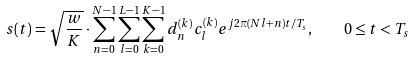<formula> <loc_0><loc_0><loc_500><loc_500>s ( t ) = \sqrt { \frac { w } { K } } \cdot \sum _ { n = 0 } ^ { N - 1 } \sum _ { l = 0 } ^ { L - 1 } \sum _ { k = 0 } ^ { K - 1 } d _ { n } ^ { ( k ) } c _ { l } ^ { ( k ) } e ^ { j 2 \pi ( N l + n ) t / T _ { s } } , \quad 0 \leq t < T _ { s }</formula> 